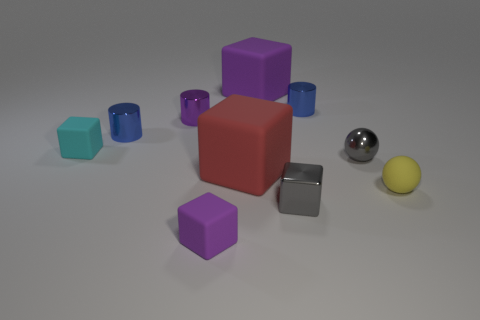Subtract all red blocks. How many blocks are left? 4 Subtract 2 blocks. How many blocks are left? 3 Subtract all big red rubber blocks. How many blocks are left? 4 Subtract all yellow blocks. Subtract all blue spheres. How many blocks are left? 5 Subtract all cylinders. How many objects are left? 7 Add 1 tiny cyan metal spheres. How many tiny cyan metal spheres exist? 1 Subtract 2 purple cubes. How many objects are left? 8 Subtract all tiny spheres. Subtract all red matte cubes. How many objects are left? 7 Add 3 matte objects. How many matte objects are left? 8 